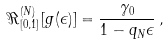Convert formula to latex. <formula><loc_0><loc_0><loc_500><loc_500>\Re ^ { ( N ) } _ { [ 0 , 1 ] } [ g ( \epsilon ) ] = \frac { \gamma _ { 0 } } { 1 - q _ { N } \epsilon } \, ,</formula> 